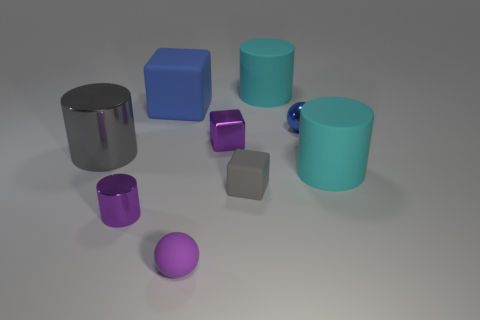What number of other things are there of the same color as the small rubber sphere?
Keep it short and to the point. 2. What color is the matte cylinder in front of the metal thing on the left side of the shiny thing that is in front of the gray metallic object?
Give a very brief answer. Cyan. Is the number of blue cubes in front of the shiny cube the same as the number of red metal things?
Your answer should be compact. Yes. Is the size of the purple shiny thing in front of the gray rubber block the same as the large gray metallic thing?
Give a very brief answer. No. What number of big cylinders are there?
Your answer should be compact. 3. How many matte things are both behind the tiny blue shiny thing and on the left side of the purple metal block?
Your response must be concise. 1. Is there a small purple object that has the same material as the tiny purple cylinder?
Your answer should be very brief. Yes. There is a large gray cylinder that is in front of the blue ball that is in front of the blue block; what is its material?
Keep it short and to the point. Metal. Are there the same number of things in front of the large blue matte block and things that are to the right of the tiny metallic cylinder?
Offer a very short reply. Yes. Is the shape of the large blue matte object the same as the tiny gray matte thing?
Give a very brief answer. Yes. 